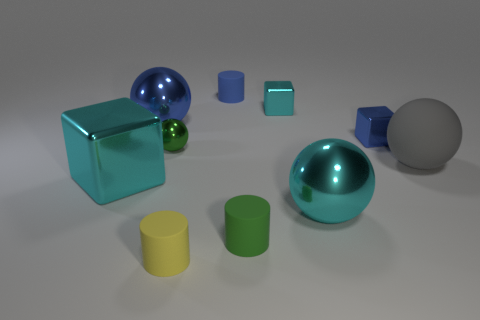Subtract all blocks. How many objects are left? 7 Subtract 1 green cylinders. How many objects are left? 9 Subtract all large blue objects. Subtract all big yellow objects. How many objects are left? 9 Add 3 shiny cubes. How many shiny cubes are left? 6 Add 1 tiny red metal cylinders. How many tiny red metal cylinders exist? 1 